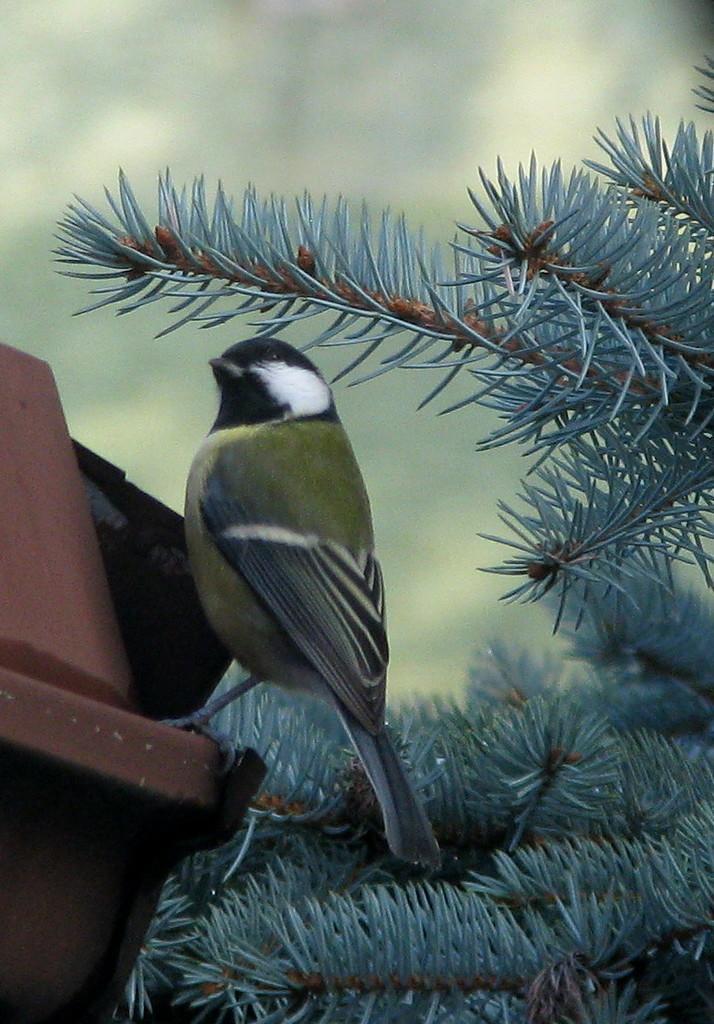How would you summarize this image in a sentence or two? In this picture I can see there is a bird at the right side, it is sitting on a brown color object. There is a plant at right and it has few leaves and the backdrop is blurred. 